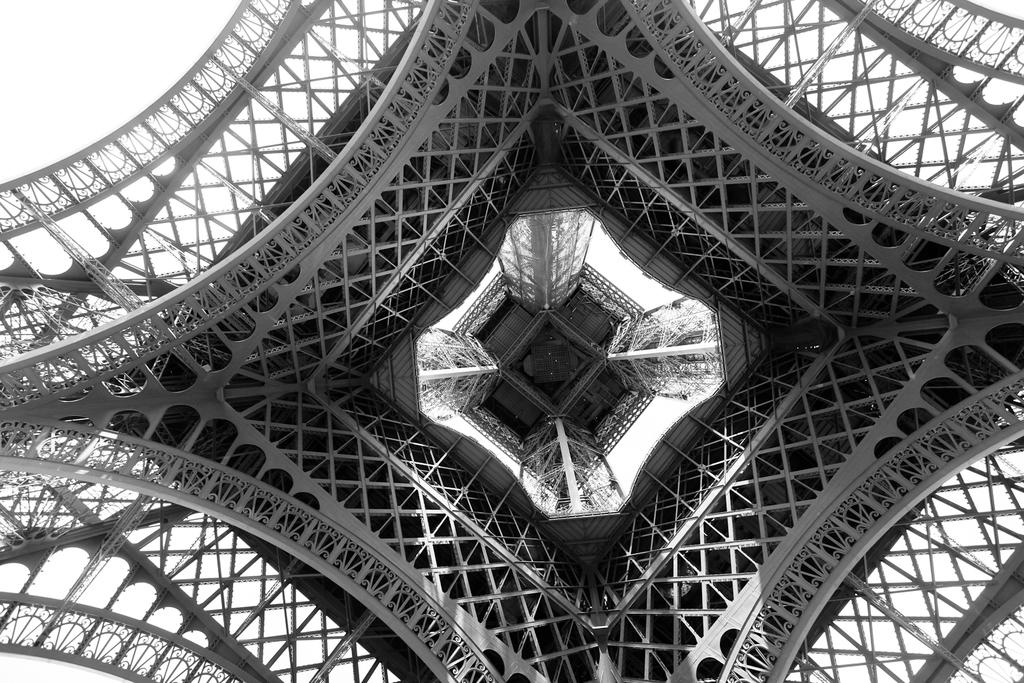What is the color scheme of the image? The image is in black and white. What is the main subject of the image? There is a tower in the image. From where was the image taken? The image appears to be taken from under the tower. What color is the background of the image? The background of the image is white. What time of day is depicted in the image, and how does it relate to the feeling of shame? The image is in black and white, so it does not depict a specific time of day. Additionally, there is no indication of shame in the image. 